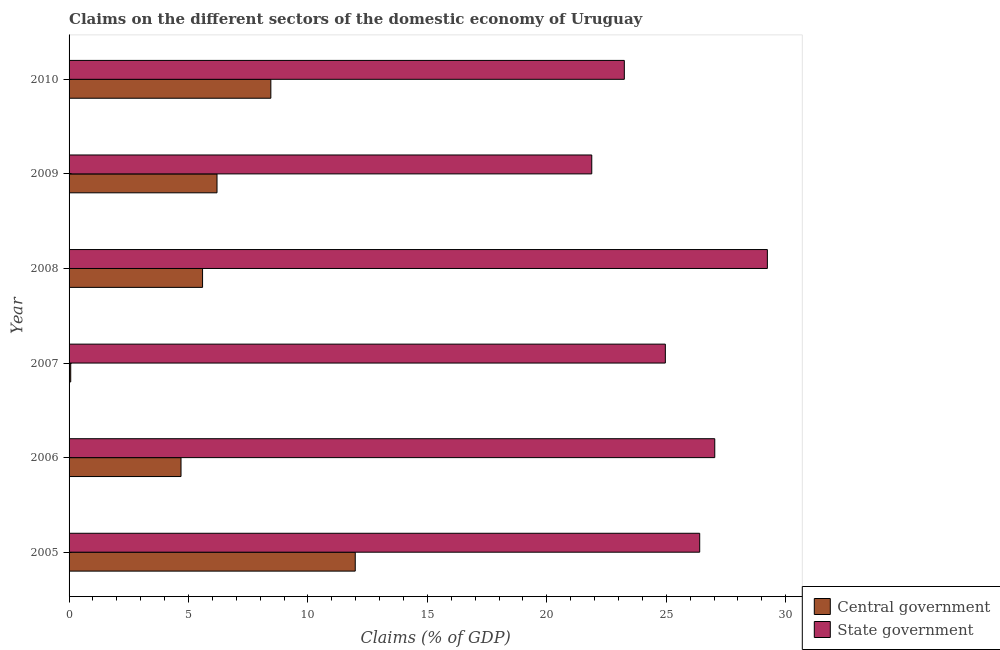How many groups of bars are there?
Make the answer very short. 6. Are the number of bars per tick equal to the number of legend labels?
Provide a short and direct response. Yes. How many bars are there on the 5th tick from the top?
Your answer should be compact. 2. How many bars are there on the 2nd tick from the bottom?
Your answer should be very brief. 2. What is the label of the 1st group of bars from the top?
Offer a very short reply. 2010. In how many cases, is the number of bars for a given year not equal to the number of legend labels?
Give a very brief answer. 0. What is the claims on central government in 2006?
Offer a very short reply. 4.69. Across all years, what is the maximum claims on state government?
Your answer should be very brief. 29.23. Across all years, what is the minimum claims on central government?
Make the answer very short. 0.07. What is the total claims on state government in the graph?
Your answer should be compact. 152.74. What is the difference between the claims on state government in 2006 and that in 2009?
Your answer should be compact. 5.15. What is the difference between the claims on central government in 2008 and the claims on state government in 2007?
Your response must be concise. -19.37. What is the average claims on state government per year?
Keep it short and to the point. 25.46. In the year 2007, what is the difference between the claims on state government and claims on central government?
Provide a short and direct response. 24.89. What is the ratio of the claims on central government in 2006 to that in 2010?
Your response must be concise. 0.56. Is the claims on state government in 2007 less than that in 2009?
Provide a succinct answer. No. What is the difference between the highest and the second highest claims on central government?
Give a very brief answer. 3.53. What is the difference between the highest and the lowest claims on central government?
Make the answer very short. 11.91. In how many years, is the claims on central government greater than the average claims on central government taken over all years?
Offer a very short reply. 3. What does the 1st bar from the top in 2006 represents?
Your answer should be very brief. State government. What does the 1st bar from the bottom in 2010 represents?
Keep it short and to the point. Central government. How many bars are there?
Your response must be concise. 12. How many years are there in the graph?
Give a very brief answer. 6. Are the values on the major ticks of X-axis written in scientific E-notation?
Offer a terse response. No. Does the graph contain grids?
Give a very brief answer. No. Where does the legend appear in the graph?
Your answer should be very brief. Bottom right. What is the title of the graph?
Offer a very short reply. Claims on the different sectors of the domestic economy of Uruguay. What is the label or title of the X-axis?
Ensure brevity in your answer.  Claims (% of GDP). What is the Claims (% of GDP) of Central government in 2005?
Provide a short and direct response. 11.98. What is the Claims (% of GDP) of State government in 2005?
Your response must be concise. 26.4. What is the Claims (% of GDP) of Central government in 2006?
Offer a very short reply. 4.69. What is the Claims (% of GDP) of State government in 2006?
Provide a succinct answer. 27.03. What is the Claims (% of GDP) in Central government in 2007?
Offer a terse response. 0.07. What is the Claims (% of GDP) of State government in 2007?
Your response must be concise. 24.96. What is the Claims (% of GDP) in Central government in 2008?
Provide a succinct answer. 5.59. What is the Claims (% of GDP) of State government in 2008?
Make the answer very short. 29.23. What is the Claims (% of GDP) of Central government in 2009?
Your answer should be very brief. 6.19. What is the Claims (% of GDP) of State government in 2009?
Keep it short and to the point. 21.88. What is the Claims (% of GDP) of Central government in 2010?
Give a very brief answer. 8.45. What is the Claims (% of GDP) in State government in 2010?
Keep it short and to the point. 23.24. Across all years, what is the maximum Claims (% of GDP) of Central government?
Your response must be concise. 11.98. Across all years, what is the maximum Claims (% of GDP) of State government?
Your answer should be very brief. 29.23. Across all years, what is the minimum Claims (% of GDP) of Central government?
Ensure brevity in your answer.  0.07. Across all years, what is the minimum Claims (% of GDP) of State government?
Offer a terse response. 21.88. What is the total Claims (% of GDP) in Central government in the graph?
Provide a short and direct response. 36.96. What is the total Claims (% of GDP) of State government in the graph?
Keep it short and to the point. 152.74. What is the difference between the Claims (% of GDP) in Central government in 2005 and that in 2006?
Provide a succinct answer. 7.29. What is the difference between the Claims (% of GDP) in State government in 2005 and that in 2006?
Your answer should be compact. -0.63. What is the difference between the Claims (% of GDP) in Central government in 2005 and that in 2007?
Your answer should be compact. 11.91. What is the difference between the Claims (% of GDP) of State government in 2005 and that in 2007?
Give a very brief answer. 1.44. What is the difference between the Claims (% of GDP) of Central government in 2005 and that in 2008?
Provide a short and direct response. 6.39. What is the difference between the Claims (% of GDP) in State government in 2005 and that in 2008?
Give a very brief answer. -2.83. What is the difference between the Claims (% of GDP) of Central government in 2005 and that in 2009?
Your answer should be very brief. 5.79. What is the difference between the Claims (% of GDP) of State government in 2005 and that in 2009?
Make the answer very short. 4.52. What is the difference between the Claims (% of GDP) in Central government in 2005 and that in 2010?
Provide a short and direct response. 3.53. What is the difference between the Claims (% of GDP) in State government in 2005 and that in 2010?
Provide a succinct answer. 3.16. What is the difference between the Claims (% of GDP) in Central government in 2006 and that in 2007?
Your response must be concise. 4.62. What is the difference between the Claims (% of GDP) of State government in 2006 and that in 2007?
Provide a succinct answer. 2.07. What is the difference between the Claims (% of GDP) of Central government in 2006 and that in 2008?
Make the answer very short. -0.9. What is the difference between the Claims (% of GDP) in State government in 2006 and that in 2008?
Provide a succinct answer. -2.2. What is the difference between the Claims (% of GDP) of Central government in 2006 and that in 2009?
Offer a very short reply. -1.51. What is the difference between the Claims (% of GDP) in State government in 2006 and that in 2009?
Keep it short and to the point. 5.15. What is the difference between the Claims (% of GDP) of Central government in 2006 and that in 2010?
Offer a terse response. -3.76. What is the difference between the Claims (% of GDP) in State government in 2006 and that in 2010?
Make the answer very short. 3.79. What is the difference between the Claims (% of GDP) in Central government in 2007 and that in 2008?
Provide a succinct answer. -5.52. What is the difference between the Claims (% of GDP) of State government in 2007 and that in 2008?
Provide a short and direct response. -4.27. What is the difference between the Claims (% of GDP) in Central government in 2007 and that in 2009?
Offer a terse response. -6.12. What is the difference between the Claims (% of GDP) of State government in 2007 and that in 2009?
Provide a short and direct response. 3.08. What is the difference between the Claims (% of GDP) in Central government in 2007 and that in 2010?
Offer a very short reply. -8.38. What is the difference between the Claims (% of GDP) in State government in 2007 and that in 2010?
Provide a succinct answer. 1.72. What is the difference between the Claims (% of GDP) in Central government in 2008 and that in 2009?
Your answer should be very brief. -0.6. What is the difference between the Claims (% of GDP) of State government in 2008 and that in 2009?
Your answer should be compact. 7.35. What is the difference between the Claims (% of GDP) in Central government in 2008 and that in 2010?
Offer a very short reply. -2.86. What is the difference between the Claims (% of GDP) in State government in 2008 and that in 2010?
Your response must be concise. 5.99. What is the difference between the Claims (% of GDP) of Central government in 2009 and that in 2010?
Offer a very short reply. -2.25. What is the difference between the Claims (% of GDP) of State government in 2009 and that in 2010?
Your response must be concise. -1.36. What is the difference between the Claims (% of GDP) in Central government in 2005 and the Claims (% of GDP) in State government in 2006?
Ensure brevity in your answer.  -15.05. What is the difference between the Claims (% of GDP) in Central government in 2005 and the Claims (% of GDP) in State government in 2007?
Give a very brief answer. -12.98. What is the difference between the Claims (% of GDP) of Central government in 2005 and the Claims (% of GDP) of State government in 2008?
Ensure brevity in your answer.  -17.25. What is the difference between the Claims (% of GDP) of Central government in 2005 and the Claims (% of GDP) of State government in 2009?
Provide a short and direct response. -9.9. What is the difference between the Claims (% of GDP) of Central government in 2005 and the Claims (% of GDP) of State government in 2010?
Ensure brevity in your answer.  -11.26. What is the difference between the Claims (% of GDP) in Central government in 2006 and the Claims (% of GDP) in State government in 2007?
Give a very brief answer. -20.27. What is the difference between the Claims (% of GDP) of Central government in 2006 and the Claims (% of GDP) of State government in 2008?
Provide a short and direct response. -24.54. What is the difference between the Claims (% of GDP) in Central government in 2006 and the Claims (% of GDP) in State government in 2009?
Your answer should be compact. -17.19. What is the difference between the Claims (% of GDP) of Central government in 2006 and the Claims (% of GDP) of State government in 2010?
Keep it short and to the point. -18.56. What is the difference between the Claims (% of GDP) of Central government in 2007 and the Claims (% of GDP) of State government in 2008?
Provide a succinct answer. -29.16. What is the difference between the Claims (% of GDP) of Central government in 2007 and the Claims (% of GDP) of State government in 2009?
Your response must be concise. -21.81. What is the difference between the Claims (% of GDP) of Central government in 2007 and the Claims (% of GDP) of State government in 2010?
Provide a short and direct response. -23.17. What is the difference between the Claims (% of GDP) in Central government in 2008 and the Claims (% of GDP) in State government in 2009?
Offer a very short reply. -16.29. What is the difference between the Claims (% of GDP) in Central government in 2008 and the Claims (% of GDP) in State government in 2010?
Your answer should be very brief. -17.66. What is the difference between the Claims (% of GDP) in Central government in 2009 and the Claims (% of GDP) in State government in 2010?
Provide a short and direct response. -17.05. What is the average Claims (% of GDP) of Central government per year?
Your response must be concise. 6.16. What is the average Claims (% of GDP) in State government per year?
Your answer should be compact. 25.46. In the year 2005, what is the difference between the Claims (% of GDP) of Central government and Claims (% of GDP) of State government?
Offer a very short reply. -14.42. In the year 2006, what is the difference between the Claims (% of GDP) of Central government and Claims (% of GDP) of State government?
Your response must be concise. -22.34. In the year 2007, what is the difference between the Claims (% of GDP) in Central government and Claims (% of GDP) in State government?
Keep it short and to the point. -24.89. In the year 2008, what is the difference between the Claims (% of GDP) of Central government and Claims (% of GDP) of State government?
Your answer should be compact. -23.64. In the year 2009, what is the difference between the Claims (% of GDP) in Central government and Claims (% of GDP) in State government?
Provide a succinct answer. -15.69. In the year 2010, what is the difference between the Claims (% of GDP) in Central government and Claims (% of GDP) in State government?
Offer a very short reply. -14.8. What is the ratio of the Claims (% of GDP) of Central government in 2005 to that in 2006?
Your response must be concise. 2.56. What is the ratio of the Claims (% of GDP) in State government in 2005 to that in 2006?
Your response must be concise. 0.98. What is the ratio of the Claims (% of GDP) of Central government in 2005 to that in 2007?
Your answer should be very brief. 173.11. What is the ratio of the Claims (% of GDP) in State government in 2005 to that in 2007?
Provide a short and direct response. 1.06. What is the ratio of the Claims (% of GDP) in Central government in 2005 to that in 2008?
Your answer should be very brief. 2.14. What is the ratio of the Claims (% of GDP) in State government in 2005 to that in 2008?
Ensure brevity in your answer.  0.9. What is the ratio of the Claims (% of GDP) in Central government in 2005 to that in 2009?
Keep it short and to the point. 1.93. What is the ratio of the Claims (% of GDP) of State government in 2005 to that in 2009?
Ensure brevity in your answer.  1.21. What is the ratio of the Claims (% of GDP) of Central government in 2005 to that in 2010?
Ensure brevity in your answer.  1.42. What is the ratio of the Claims (% of GDP) in State government in 2005 to that in 2010?
Ensure brevity in your answer.  1.14. What is the ratio of the Claims (% of GDP) in Central government in 2006 to that in 2007?
Offer a very short reply. 67.71. What is the ratio of the Claims (% of GDP) in State government in 2006 to that in 2007?
Keep it short and to the point. 1.08. What is the ratio of the Claims (% of GDP) in Central government in 2006 to that in 2008?
Provide a short and direct response. 0.84. What is the ratio of the Claims (% of GDP) of State government in 2006 to that in 2008?
Provide a short and direct response. 0.92. What is the ratio of the Claims (% of GDP) of Central government in 2006 to that in 2009?
Ensure brevity in your answer.  0.76. What is the ratio of the Claims (% of GDP) in State government in 2006 to that in 2009?
Provide a short and direct response. 1.24. What is the ratio of the Claims (% of GDP) of Central government in 2006 to that in 2010?
Offer a very short reply. 0.55. What is the ratio of the Claims (% of GDP) of State government in 2006 to that in 2010?
Give a very brief answer. 1.16. What is the ratio of the Claims (% of GDP) of Central government in 2007 to that in 2008?
Make the answer very short. 0.01. What is the ratio of the Claims (% of GDP) in State government in 2007 to that in 2008?
Your response must be concise. 0.85. What is the ratio of the Claims (% of GDP) in Central government in 2007 to that in 2009?
Offer a terse response. 0.01. What is the ratio of the Claims (% of GDP) of State government in 2007 to that in 2009?
Provide a short and direct response. 1.14. What is the ratio of the Claims (% of GDP) in Central government in 2007 to that in 2010?
Offer a very short reply. 0.01. What is the ratio of the Claims (% of GDP) of State government in 2007 to that in 2010?
Provide a succinct answer. 1.07. What is the ratio of the Claims (% of GDP) in Central government in 2008 to that in 2009?
Provide a short and direct response. 0.9. What is the ratio of the Claims (% of GDP) of State government in 2008 to that in 2009?
Offer a very short reply. 1.34. What is the ratio of the Claims (% of GDP) of Central government in 2008 to that in 2010?
Your answer should be compact. 0.66. What is the ratio of the Claims (% of GDP) of State government in 2008 to that in 2010?
Offer a terse response. 1.26. What is the ratio of the Claims (% of GDP) in Central government in 2009 to that in 2010?
Ensure brevity in your answer.  0.73. What is the ratio of the Claims (% of GDP) in State government in 2009 to that in 2010?
Keep it short and to the point. 0.94. What is the difference between the highest and the second highest Claims (% of GDP) of Central government?
Ensure brevity in your answer.  3.53. What is the difference between the highest and the second highest Claims (% of GDP) in State government?
Keep it short and to the point. 2.2. What is the difference between the highest and the lowest Claims (% of GDP) in Central government?
Offer a very short reply. 11.91. What is the difference between the highest and the lowest Claims (% of GDP) of State government?
Offer a very short reply. 7.35. 